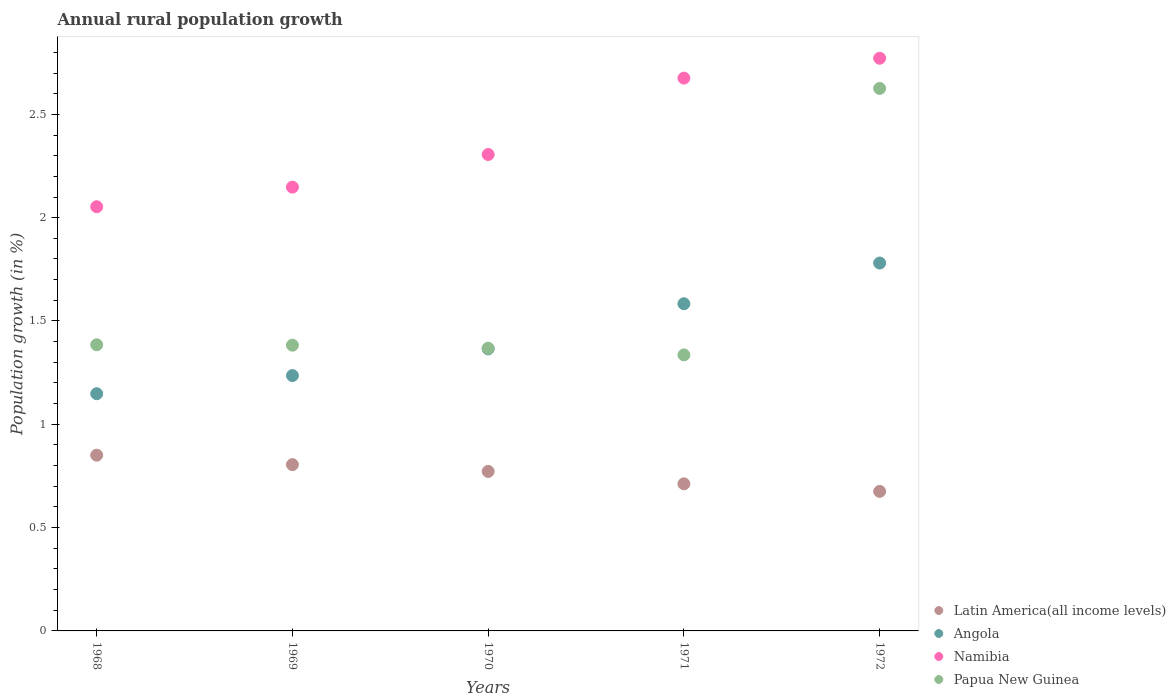Is the number of dotlines equal to the number of legend labels?
Your response must be concise. Yes. What is the percentage of rural population growth in Latin America(all income levels) in 1970?
Provide a short and direct response. 0.77. Across all years, what is the maximum percentage of rural population growth in Papua New Guinea?
Provide a succinct answer. 2.63. Across all years, what is the minimum percentage of rural population growth in Latin America(all income levels)?
Your answer should be compact. 0.68. In which year was the percentage of rural population growth in Namibia maximum?
Your answer should be very brief. 1972. What is the total percentage of rural population growth in Angola in the graph?
Provide a short and direct response. 7.11. What is the difference between the percentage of rural population growth in Namibia in 1971 and that in 1972?
Give a very brief answer. -0.1. What is the difference between the percentage of rural population growth in Latin America(all income levels) in 1972 and the percentage of rural population growth in Namibia in 1968?
Keep it short and to the point. -1.38. What is the average percentage of rural population growth in Angola per year?
Ensure brevity in your answer.  1.42. In the year 1970, what is the difference between the percentage of rural population growth in Latin America(all income levels) and percentage of rural population growth in Namibia?
Your answer should be compact. -1.53. In how many years, is the percentage of rural population growth in Angola greater than 0.1 %?
Your response must be concise. 5. What is the ratio of the percentage of rural population growth in Namibia in 1971 to that in 1972?
Offer a very short reply. 0.97. Is the difference between the percentage of rural population growth in Latin America(all income levels) in 1969 and 1970 greater than the difference between the percentage of rural population growth in Namibia in 1969 and 1970?
Offer a terse response. Yes. What is the difference between the highest and the second highest percentage of rural population growth in Latin America(all income levels)?
Your answer should be very brief. 0.05. What is the difference between the highest and the lowest percentage of rural population growth in Latin America(all income levels)?
Provide a succinct answer. 0.18. Is the sum of the percentage of rural population growth in Angola in 1968 and 1970 greater than the maximum percentage of rural population growth in Latin America(all income levels) across all years?
Your answer should be very brief. Yes. Is it the case that in every year, the sum of the percentage of rural population growth in Namibia and percentage of rural population growth in Angola  is greater than the sum of percentage of rural population growth in Latin America(all income levels) and percentage of rural population growth in Papua New Guinea?
Keep it short and to the point. No. Is it the case that in every year, the sum of the percentage of rural population growth in Papua New Guinea and percentage of rural population growth in Angola  is greater than the percentage of rural population growth in Namibia?
Offer a very short reply. Yes. Does the percentage of rural population growth in Latin America(all income levels) monotonically increase over the years?
Give a very brief answer. No. Is the percentage of rural population growth in Namibia strictly greater than the percentage of rural population growth in Papua New Guinea over the years?
Ensure brevity in your answer.  Yes. Is the percentage of rural population growth in Latin America(all income levels) strictly less than the percentage of rural population growth in Namibia over the years?
Ensure brevity in your answer.  Yes. How many dotlines are there?
Your answer should be compact. 4. Does the graph contain grids?
Your answer should be very brief. No. How many legend labels are there?
Your answer should be compact. 4. How are the legend labels stacked?
Your response must be concise. Vertical. What is the title of the graph?
Offer a terse response. Annual rural population growth. Does "Mauritania" appear as one of the legend labels in the graph?
Ensure brevity in your answer.  No. What is the label or title of the Y-axis?
Keep it short and to the point. Population growth (in %). What is the Population growth (in %) of Latin America(all income levels) in 1968?
Your answer should be compact. 0.85. What is the Population growth (in %) in Angola in 1968?
Your answer should be compact. 1.15. What is the Population growth (in %) of Namibia in 1968?
Your answer should be compact. 2.05. What is the Population growth (in %) in Papua New Guinea in 1968?
Your answer should be compact. 1.38. What is the Population growth (in %) in Latin America(all income levels) in 1969?
Give a very brief answer. 0.8. What is the Population growth (in %) of Angola in 1969?
Offer a very short reply. 1.24. What is the Population growth (in %) of Namibia in 1969?
Provide a short and direct response. 2.15. What is the Population growth (in %) of Papua New Guinea in 1969?
Your answer should be very brief. 1.38. What is the Population growth (in %) of Latin America(all income levels) in 1970?
Offer a very short reply. 0.77. What is the Population growth (in %) in Angola in 1970?
Offer a very short reply. 1.36. What is the Population growth (in %) of Namibia in 1970?
Provide a succinct answer. 2.31. What is the Population growth (in %) of Papua New Guinea in 1970?
Ensure brevity in your answer.  1.37. What is the Population growth (in %) of Latin America(all income levels) in 1971?
Provide a short and direct response. 0.71. What is the Population growth (in %) in Angola in 1971?
Make the answer very short. 1.58. What is the Population growth (in %) of Namibia in 1971?
Your answer should be very brief. 2.68. What is the Population growth (in %) in Papua New Guinea in 1971?
Give a very brief answer. 1.34. What is the Population growth (in %) of Latin America(all income levels) in 1972?
Your response must be concise. 0.68. What is the Population growth (in %) of Angola in 1972?
Offer a very short reply. 1.78. What is the Population growth (in %) of Namibia in 1972?
Ensure brevity in your answer.  2.77. What is the Population growth (in %) of Papua New Guinea in 1972?
Ensure brevity in your answer.  2.63. Across all years, what is the maximum Population growth (in %) of Latin America(all income levels)?
Offer a very short reply. 0.85. Across all years, what is the maximum Population growth (in %) of Angola?
Keep it short and to the point. 1.78. Across all years, what is the maximum Population growth (in %) in Namibia?
Your answer should be very brief. 2.77. Across all years, what is the maximum Population growth (in %) in Papua New Guinea?
Provide a succinct answer. 2.63. Across all years, what is the minimum Population growth (in %) of Latin America(all income levels)?
Offer a terse response. 0.68. Across all years, what is the minimum Population growth (in %) in Angola?
Ensure brevity in your answer.  1.15. Across all years, what is the minimum Population growth (in %) in Namibia?
Your answer should be compact. 2.05. Across all years, what is the minimum Population growth (in %) in Papua New Guinea?
Your response must be concise. 1.34. What is the total Population growth (in %) in Latin America(all income levels) in the graph?
Provide a short and direct response. 3.81. What is the total Population growth (in %) in Angola in the graph?
Make the answer very short. 7.11. What is the total Population growth (in %) in Namibia in the graph?
Your answer should be compact. 11.95. What is the total Population growth (in %) of Papua New Guinea in the graph?
Your response must be concise. 8.1. What is the difference between the Population growth (in %) of Latin America(all income levels) in 1968 and that in 1969?
Keep it short and to the point. 0.05. What is the difference between the Population growth (in %) in Angola in 1968 and that in 1969?
Give a very brief answer. -0.09. What is the difference between the Population growth (in %) in Namibia in 1968 and that in 1969?
Provide a short and direct response. -0.09. What is the difference between the Population growth (in %) in Papua New Guinea in 1968 and that in 1969?
Offer a very short reply. 0. What is the difference between the Population growth (in %) of Latin America(all income levels) in 1968 and that in 1970?
Provide a succinct answer. 0.08. What is the difference between the Population growth (in %) of Angola in 1968 and that in 1970?
Ensure brevity in your answer.  -0.22. What is the difference between the Population growth (in %) of Namibia in 1968 and that in 1970?
Make the answer very short. -0.25. What is the difference between the Population growth (in %) in Papua New Guinea in 1968 and that in 1970?
Your response must be concise. 0.02. What is the difference between the Population growth (in %) in Latin America(all income levels) in 1968 and that in 1971?
Offer a very short reply. 0.14. What is the difference between the Population growth (in %) of Angola in 1968 and that in 1971?
Make the answer very short. -0.44. What is the difference between the Population growth (in %) of Namibia in 1968 and that in 1971?
Give a very brief answer. -0.62. What is the difference between the Population growth (in %) in Papua New Guinea in 1968 and that in 1971?
Keep it short and to the point. 0.05. What is the difference between the Population growth (in %) in Latin America(all income levels) in 1968 and that in 1972?
Give a very brief answer. 0.18. What is the difference between the Population growth (in %) of Angola in 1968 and that in 1972?
Give a very brief answer. -0.63. What is the difference between the Population growth (in %) in Namibia in 1968 and that in 1972?
Offer a very short reply. -0.72. What is the difference between the Population growth (in %) of Papua New Guinea in 1968 and that in 1972?
Make the answer very short. -1.24. What is the difference between the Population growth (in %) in Latin America(all income levels) in 1969 and that in 1970?
Offer a very short reply. 0.03. What is the difference between the Population growth (in %) in Angola in 1969 and that in 1970?
Offer a very short reply. -0.13. What is the difference between the Population growth (in %) of Namibia in 1969 and that in 1970?
Offer a terse response. -0.16. What is the difference between the Population growth (in %) of Papua New Guinea in 1969 and that in 1970?
Offer a terse response. 0.01. What is the difference between the Population growth (in %) in Latin America(all income levels) in 1969 and that in 1971?
Your answer should be very brief. 0.09. What is the difference between the Population growth (in %) of Angola in 1969 and that in 1971?
Provide a succinct answer. -0.35. What is the difference between the Population growth (in %) of Namibia in 1969 and that in 1971?
Your answer should be very brief. -0.53. What is the difference between the Population growth (in %) in Papua New Guinea in 1969 and that in 1971?
Offer a very short reply. 0.05. What is the difference between the Population growth (in %) in Latin America(all income levels) in 1969 and that in 1972?
Ensure brevity in your answer.  0.13. What is the difference between the Population growth (in %) of Angola in 1969 and that in 1972?
Provide a short and direct response. -0.54. What is the difference between the Population growth (in %) in Namibia in 1969 and that in 1972?
Your answer should be very brief. -0.62. What is the difference between the Population growth (in %) in Papua New Guinea in 1969 and that in 1972?
Ensure brevity in your answer.  -1.24. What is the difference between the Population growth (in %) in Latin America(all income levels) in 1970 and that in 1971?
Offer a terse response. 0.06. What is the difference between the Population growth (in %) of Angola in 1970 and that in 1971?
Make the answer very short. -0.22. What is the difference between the Population growth (in %) of Namibia in 1970 and that in 1971?
Ensure brevity in your answer.  -0.37. What is the difference between the Population growth (in %) in Papua New Guinea in 1970 and that in 1971?
Provide a short and direct response. 0.03. What is the difference between the Population growth (in %) in Latin America(all income levels) in 1970 and that in 1972?
Give a very brief answer. 0.1. What is the difference between the Population growth (in %) of Angola in 1970 and that in 1972?
Give a very brief answer. -0.42. What is the difference between the Population growth (in %) in Namibia in 1970 and that in 1972?
Give a very brief answer. -0.47. What is the difference between the Population growth (in %) in Papua New Guinea in 1970 and that in 1972?
Offer a very short reply. -1.26. What is the difference between the Population growth (in %) of Latin America(all income levels) in 1971 and that in 1972?
Offer a terse response. 0.04. What is the difference between the Population growth (in %) of Angola in 1971 and that in 1972?
Keep it short and to the point. -0.2. What is the difference between the Population growth (in %) in Namibia in 1971 and that in 1972?
Give a very brief answer. -0.1. What is the difference between the Population growth (in %) of Papua New Guinea in 1971 and that in 1972?
Your answer should be very brief. -1.29. What is the difference between the Population growth (in %) in Latin America(all income levels) in 1968 and the Population growth (in %) in Angola in 1969?
Offer a very short reply. -0.39. What is the difference between the Population growth (in %) of Latin America(all income levels) in 1968 and the Population growth (in %) of Namibia in 1969?
Give a very brief answer. -1.3. What is the difference between the Population growth (in %) in Latin America(all income levels) in 1968 and the Population growth (in %) in Papua New Guinea in 1969?
Your answer should be very brief. -0.53. What is the difference between the Population growth (in %) of Angola in 1968 and the Population growth (in %) of Namibia in 1969?
Your answer should be very brief. -1. What is the difference between the Population growth (in %) of Angola in 1968 and the Population growth (in %) of Papua New Guinea in 1969?
Make the answer very short. -0.23. What is the difference between the Population growth (in %) in Namibia in 1968 and the Population growth (in %) in Papua New Guinea in 1969?
Offer a very short reply. 0.67. What is the difference between the Population growth (in %) in Latin America(all income levels) in 1968 and the Population growth (in %) in Angola in 1970?
Provide a short and direct response. -0.51. What is the difference between the Population growth (in %) in Latin America(all income levels) in 1968 and the Population growth (in %) in Namibia in 1970?
Keep it short and to the point. -1.46. What is the difference between the Population growth (in %) in Latin America(all income levels) in 1968 and the Population growth (in %) in Papua New Guinea in 1970?
Give a very brief answer. -0.52. What is the difference between the Population growth (in %) in Angola in 1968 and the Population growth (in %) in Namibia in 1970?
Your response must be concise. -1.16. What is the difference between the Population growth (in %) in Angola in 1968 and the Population growth (in %) in Papua New Guinea in 1970?
Provide a succinct answer. -0.22. What is the difference between the Population growth (in %) in Namibia in 1968 and the Population growth (in %) in Papua New Guinea in 1970?
Provide a succinct answer. 0.68. What is the difference between the Population growth (in %) of Latin America(all income levels) in 1968 and the Population growth (in %) of Angola in 1971?
Provide a short and direct response. -0.73. What is the difference between the Population growth (in %) in Latin America(all income levels) in 1968 and the Population growth (in %) in Namibia in 1971?
Provide a short and direct response. -1.82. What is the difference between the Population growth (in %) in Latin America(all income levels) in 1968 and the Population growth (in %) in Papua New Guinea in 1971?
Provide a short and direct response. -0.49. What is the difference between the Population growth (in %) in Angola in 1968 and the Population growth (in %) in Namibia in 1971?
Provide a short and direct response. -1.53. What is the difference between the Population growth (in %) in Angola in 1968 and the Population growth (in %) in Papua New Guinea in 1971?
Your response must be concise. -0.19. What is the difference between the Population growth (in %) in Namibia in 1968 and the Population growth (in %) in Papua New Guinea in 1971?
Keep it short and to the point. 0.72. What is the difference between the Population growth (in %) in Latin America(all income levels) in 1968 and the Population growth (in %) in Angola in 1972?
Your answer should be compact. -0.93. What is the difference between the Population growth (in %) in Latin America(all income levels) in 1968 and the Population growth (in %) in Namibia in 1972?
Offer a very short reply. -1.92. What is the difference between the Population growth (in %) in Latin America(all income levels) in 1968 and the Population growth (in %) in Papua New Guinea in 1972?
Provide a short and direct response. -1.77. What is the difference between the Population growth (in %) of Angola in 1968 and the Population growth (in %) of Namibia in 1972?
Your answer should be compact. -1.62. What is the difference between the Population growth (in %) of Angola in 1968 and the Population growth (in %) of Papua New Guinea in 1972?
Give a very brief answer. -1.48. What is the difference between the Population growth (in %) in Namibia in 1968 and the Population growth (in %) in Papua New Guinea in 1972?
Your response must be concise. -0.57. What is the difference between the Population growth (in %) of Latin America(all income levels) in 1969 and the Population growth (in %) of Angola in 1970?
Your response must be concise. -0.56. What is the difference between the Population growth (in %) of Latin America(all income levels) in 1969 and the Population growth (in %) of Namibia in 1970?
Provide a short and direct response. -1.5. What is the difference between the Population growth (in %) of Latin America(all income levels) in 1969 and the Population growth (in %) of Papua New Guinea in 1970?
Your answer should be compact. -0.56. What is the difference between the Population growth (in %) in Angola in 1969 and the Population growth (in %) in Namibia in 1970?
Keep it short and to the point. -1.07. What is the difference between the Population growth (in %) in Angola in 1969 and the Population growth (in %) in Papua New Guinea in 1970?
Your answer should be compact. -0.13. What is the difference between the Population growth (in %) in Namibia in 1969 and the Population growth (in %) in Papua New Guinea in 1970?
Give a very brief answer. 0.78. What is the difference between the Population growth (in %) in Latin America(all income levels) in 1969 and the Population growth (in %) in Angola in 1971?
Give a very brief answer. -0.78. What is the difference between the Population growth (in %) in Latin America(all income levels) in 1969 and the Population growth (in %) in Namibia in 1971?
Your answer should be very brief. -1.87. What is the difference between the Population growth (in %) in Latin America(all income levels) in 1969 and the Population growth (in %) in Papua New Guinea in 1971?
Offer a terse response. -0.53. What is the difference between the Population growth (in %) of Angola in 1969 and the Population growth (in %) of Namibia in 1971?
Offer a terse response. -1.44. What is the difference between the Population growth (in %) in Angola in 1969 and the Population growth (in %) in Papua New Guinea in 1971?
Offer a terse response. -0.1. What is the difference between the Population growth (in %) in Namibia in 1969 and the Population growth (in %) in Papua New Guinea in 1971?
Your response must be concise. 0.81. What is the difference between the Population growth (in %) of Latin America(all income levels) in 1969 and the Population growth (in %) of Angola in 1972?
Your answer should be compact. -0.98. What is the difference between the Population growth (in %) in Latin America(all income levels) in 1969 and the Population growth (in %) in Namibia in 1972?
Offer a very short reply. -1.97. What is the difference between the Population growth (in %) in Latin America(all income levels) in 1969 and the Population growth (in %) in Papua New Guinea in 1972?
Offer a very short reply. -1.82. What is the difference between the Population growth (in %) of Angola in 1969 and the Population growth (in %) of Namibia in 1972?
Make the answer very short. -1.54. What is the difference between the Population growth (in %) in Angola in 1969 and the Population growth (in %) in Papua New Guinea in 1972?
Keep it short and to the point. -1.39. What is the difference between the Population growth (in %) in Namibia in 1969 and the Population growth (in %) in Papua New Guinea in 1972?
Provide a succinct answer. -0.48. What is the difference between the Population growth (in %) of Latin America(all income levels) in 1970 and the Population growth (in %) of Angola in 1971?
Make the answer very short. -0.81. What is the difference between the Population growth (in %) in Latin America(all income levels) in 1970 and the Population growth (in %) in Namibia in 1971?
Offer a very short reply. -1.9. What is the difference between the Population growth (in %) of Latin America(all income levels) in 1970 and the Population growth (in %) of Papua New Guinea in 1971?
Ensure brevity in your answer.  -0.56. What is the difference between the Population growth (in %) in Angola in 1970 and the Population growth (in %) in Namibia in 1971?
Make the answer very short. -1.31. What is the difference between the Population growth (in %) of Angola in 1970 and the Population growth (in %) of Papua New Guinea in 1971?
Your response must be concise. 0.03. What is the difference between the Population growth (in %) in Namibia in 1970 and the Population growth (in %) in Papua New Guinea in 1971?
Ensure brevity in your answer.  0.97. What is the difference between the Population growth (in %) of Latin America(all income levels) in 1970 and the Population growth (in %) of Angola in 1972?
Provide a short and direct response. -1.01. What is the difference between the Population growth (in %) in Latin America(all income levels) in 1970 and the Population growth (in %) in Namibia in 1972?
Make the answer very short. -2. What is the difference between the Population growth (in %) in Latin America(all income levels) in 1970 and the Population growth (in %) in Papua New Guinea in 1972?
Your answer should be compact. -1.85. What is the difference between the Population growth (in %) of Angola in 1970 and the Population growth (in %) of Namibia in 1972?
Make the answer very short. -1.41. What is the difference between the Population growth (in %) of Angola in 1970 and the Population growth (in %) of Papua New Guinea in 1972?
Offer a very short reply. -1.26. What is the difference between the Population growth (in %) in Namibia in 1970 and the Population growth (in %) in Papua New Guinea in 1972?
Make the answer very short. -0.32. What is the difference between the Population growth (in %) in Latin America(all income levels) in 1971 and the Population growth (in %) in Angola in 1972?
Your response must be concise. -1.07. What is the difference between the Population growth (in %) in Latin America(all income levels) in 1971 and the Population growth (in %) in Namibia in 1972?
Ensure brevity in your answer.  -2.06. What is the difference between the Population growth (in %) in Latin America(all income levels) in 1971 and the Population growth (in %) in Papua New Guinea in 1972?
Your response must be concise. -1.91. What is the difference between the Population growth (in %) in Angola in 1971 and the Population growth (in %) in Namibia in 1972?
Give a very brief answer. -1.19. What is the difference between the Population growth (in %) of Angola in 1971 and the Population growth (in %) of Papua New Guinea in 1972?
Ensure brevity in your answer.  -1.04. What is the difference between the Population growth (in %) in Namibia in 1971 and the Population growth (in %) in Papua New Guinea in 1972?
Make the answer very short. 0.05. What is the average Population growth (in %) of Latin America(all income levels) per year?
Ensure brevity in your answer.  0.76. What is the average Population growth (in %) in Angola per year?
Give a very brief answer. 1.42. What is the average Population growth (in %) of Namibia per year?
Offer a very short reply. 2.39. What is the average Population growth (in %) in Papua New Guinea per year?
Keep it short and to the point. 1.62. In the year 1968, what is the difference between the Population growth (in %) in Latin America(all income levels) and Population growth (in %) in Angola?
Your answer should be very brief. -0.3. In the year 1968, what is the difference between the Population growth (in %) in Latin America(all income levels) and Population growth (in %) in Namibia?
Keep it short and to the point. -1.2. In the year 1968, what is the difference between the Population growth (in %) of Latin America(all income levels) and Population growth (in %) of Papua New Guinea?
Your answer should be very brief. -0.53. In the year 1968, what is the difference between the Population growth (in %) of Angola and Population growth (in %) of Namibia?
Offer a terse response. -0.9. In the year 1968, what is the difference between the Population growth (in %) in Angola and Population growth (in %) in Papua New Guinea?
Ensure brevity in your answer.  -0.24. In the year 1968, what is the difference between the Population growth (in %) in Namibia and Population growth (in %) in Papua New Guinea?
Provide a succinct answer. 0.67. In the year 1969, what is the difference between the Population growth (in %) of Latin America(all income levels) and Population growth (in %) of Angola?
Keep it short and to the point. -0.43. In the year 1969, what is the difference between the Population growth (in %) in Latin America(all income levels) and Population growth (in %) in Namibia?
Give a very brief answer. -1.34. In the year 1969, what is the difference between the Population growth (in %) of Latin America(all income levels) and Population growth (in %) of Papua New Guinea?
Offer a very short reply. -0.58. In the year 1969, what is the difference between the Population growth (in %) in Angola and Population growth (in %) in Namibia?
Make the answer very short. -0.91. In the year 1969, what is the difference between the Population growth (in %) in Angola and Population growth (in %) in Papua New Guinea?
Keep it short and to the point. -0.15. In the year 1969, what is the difference between the Population growth (in %) of Namibia and Population growth (in %) of Papua New Guinea?
Your answer should be very brief. 0.76. In the year 1970, what is the difference between the Population growth (in %) of Latin America(all income levels) and Population growth (in %) of Angola?
Your answer should be very brief. -0.59. In the year 1970, what is the difference between the Population growth (in %) of Latin America(all income levels) and Population growth (in %) of Namibia?
Provide a short and direct response. -1.53. In the year 1970, what is the difference between the Population growth (in %) in Latin America(all income levels) and Population growth (in %) in Papua New Guinea?
Offer a terse response. -0.6. In the year 1970, what is the difference between the Population growth (in %) of Angola and Population growth (in %) of Namibia?
Provide a short and direct response. -0.94. In the year 1970, what is the difference between the Population growth (in %) in Angola and Population growth (in %) in Papua New Guinea?
Your response must be concise. -0. In the year 1971, what is the difference between the Population growth (in %) of Latin America(all income levels) and Population growth (in %) of Angola?
Ensure brevity in your answer.  -0.87. In the year 1971, what is the difference between the Population growth (in %) of Latin America(all income levels) and Population growth (in %) of Namibia?
Ensure brevity in your answer.  -1.96. In the year 1971, what is the difference between the Population growth (in %) of Latin America(all income levels) and Population growth (in %) of Papua New Guinea?
Keep it short and to the point. -0.62. In the year 1971, what is the difference between the Population growth (in %) of Angola and Population growth (in %) of Namibia?
Ensure brevity in your answer.  -1.09. In the year 1971, what is the difference between the Population growth (in %) of Angola and Population growth (in %) of Papua New Guinea?
Ensure brevity in your answer.  0.25. In the year 1971, what is the difference between the Population growth (in %) of Namibia and Population growth (in %) of Papua New Guinea?
Offer a terse response. 1.34. In the year 1972, what is the difference between the Population growth (in %) of Latin America(all income levels) and Population growth (in %) of Angola?
Make the answer very short. -1.11. In the year 1972, what is the difference between the Population growth (in %) of Latin America(all income levels) and Population growth (in %) of Namibia?
Offer a very short reply. -2.1. In the year 1972, what is the difference between the Population growth (in %) of Latin America(all income levels) and Population growth (in %) of Papua New Guinea?
Offer a terse response. -1.95. In the year 1972, what is the difference between the Population growth (in %) in Angola and Population growth (in %) in Namibia?
Your answer should be compact. -0.99. In the year 1972, what is the difference between the Population growth (in %) in Angola and Population growth (in %) in Papua New Guinea?
Offer a terse response. -0.84. In the year 1972, what is the difference between the Population growth (in %) of Namibia and Population growth (in %) of Papua New Guinea?
Offer a terse response. 0.15. What is the ratio of the Population growth (in %) of Latin America(all income levels) in 1968 to that in 1969?
Provide a succinct answer. 1.06. What is the ratio of the Population growth (in %) of Angola in 1968 to that in 1969?
Give a very brief answer. 0.93. What is the ratio of the Population growth (in %) of Namibia in 1968 to that in 1969?
Provide a short and direct response. 0.96. What is the ratio of the Population growth (in %) in Latin America(all income levels) in 1968 to that in 1970?
Offer a very short reply. 1.1. What is the ratio of the Population growth (in %) in Angola in 1968 to that in 1970?
Ensure brevity in your answer.  0.84. What is the ratio of the Population growth (in %) in Namibia in 1968 to that in 1970?
Provide a short and direct response. 0.89. What is the ratio of the Population growth (in %) of Papua New Guinea in 1968 to that in 1970?
Your answer should be compact. 1.01. What is the ratio of the Population growth (in %) in Latin America(all income levels) in 1968 to that in 1971?
Offer a terse response. 1.19. What is the ratio of the Population growth (in %) in Angola in 1968 to that in 1971?
Give a very brief answer. 0.73. What is the ratio of the Population growth (in %) in Namibia in 1968 to that in 1971?
Your answer should be compact. 0.77. What is the ratio of the Population growth (in %) in Papua New Guinea in 1968 to that in 1971?
Offer a terse response. 1.04. What is the ratio of the Population growth (in %) in Latin America(all income levels) in 1968 to that in 1972?
Your response must be concise. 1.26. What is the ratio of the Population growth (in %) of Angola in 1968 to that in 1972?
Your response must be concise. 0.64. What is the ratio of the Population growth (in %) in Namibia in 1968 to that in 1972?
Give a very brief answer. 0.74. What is the ratio of the Population growth (in %) in Papua New Guinea in 1968 to that in 1972?
Keep it short and to the point. 0.53. What is the ratio of the Population growth (in %) of Latin America(all income levels) in 1969 to that in 1970?
Provide a short and direct response. 1.04. What is the ratio of the Population growth (in %) of Angola in 1969 to that in 1970?
Your response must be concise. 0.91. What is the ratio of the Population growth (in %) in Namibia in 1969 to that in 1970?
Give a very brief answer. 0.93. What is the ratio of the Population growth (in %) in Papua New Guinea in 1969 to that in 1970?
Keep it short and to the point. 1.01. What is the ratio of the Population growth (in %) of Latin America(all income levels) in 1969 to that in 1971?
Make the answer very short. 1.13. What is the ratio of the Population growth (in %) in Angola in 1969 to that in 1971?
Make the answer very short. 0.78. What is the ratio of the Population growth (in %) of Namibia in 1969 to that in 1971?
Your answer should be very brief. 0.8. What is the ratio of the Population growth (in %) in Papua New Guinea in 1969 to that in 1971?
Offer a terse response. 1.04. What is the ratio of the Population growth (in %) in Latin America(all income levels) in 1969 to that in 1972?
Ensure brevity in your answer.  1.19. What is the ratio of the Population growth (in %) of Angola in 1969 to that in 1972?
Your answer should be very brief. 0.69. What is the ratio of the Population growth (in %) in Namibia in 1969 to that in 1972?
Your answer should be compact. 0.77. What is the ratio of the Population growth (in %) in Papua New Guinea in 1969 to that in 1972?
Offer a very short reply. 0.53. What is the ratio of the Population growth (in %) of Latin America(all income levels) in 1970 to that in 1971?
Your answer should be very brief. 1.08. What is the ratio of the Population growth (in %) of Angola in 1970 to that in 1971?
Offer a terse response. 0.86. What is the ratio of the Population growth (in %) of Namibia in 1970 to that in 1971?
Your answer should be very brief. 0.86. What is the ratio of the Population growth (in %) of Papua New Guinea in 1970 to that in 1971?
Offer a very short reply. 1.02. What is the ratio of the Population growth (in %) of Latin America(all income levels) in 1970 to that in 1972?
Give a very brief answer. 1.14. What is the ratio of the Population growth (in %) of Angola in 1970 to that in 1972?
Provide a succinct answer. 0.77. What is the ratio of the Population growth (in %) of Namibia in 1970 to that in 1972?
Your answer should be very brief. 0.83. What is the ratio of the Population growth (in %) of Papua New Guinea in 1970 to that in 1972?
Keep it short and to the point. 0.52. What is the ratio of the Population growth (in %) in Latin America(all income levels) in 1971 to that in 1972?
Provide a short and direct response. 1.05. What is the ratio of the Population growth (in %) in Angola in 1971 to that in 1972?
Ensure brevity in your answer.  0.89. What is the ratio of the Population growth (in %) in Namibia in 1971 to that in 1972?
Your response must be concise. 0.97. What is the ratio of the Population growth (in %) in Papua New Guinea in 1971 to that in 1972?
Provide a succinct answer. 0.51. What is the difference between the highest and the second highest Population growth (in %) in Latin America(all income levels)?
Offer a terse response. 0.05. What is the difference between the highest and the second highest Population growth (in %) in Angola?
Your answer should be compact. 0.2. What is the difference between the highest and the second highest Population growth (in %) of Namibia?
Keep it short and to the point. 0.1. What is the difference between the highest and the second highest Population growth (in %) in Papua New Guinea?
Your answer should be very brief. 1.24. What is the difference between the highest and the lowest Population growth (in %) in Latin America(all income levels)?
Offer a very short reply. 0.18. What is the difference between the highest and the lowest Population growth (in %) in Angola?
Ensure brevity in your answer.  0.63. What is the difference between the highest and the lowest Population growth (in %) of Namibia?
Your answer should be compact. 0.72. What is the difference between the highest and the lowest Population growth (in %) in Papua New Guinea?
Your answer should be compact. 1.29. 